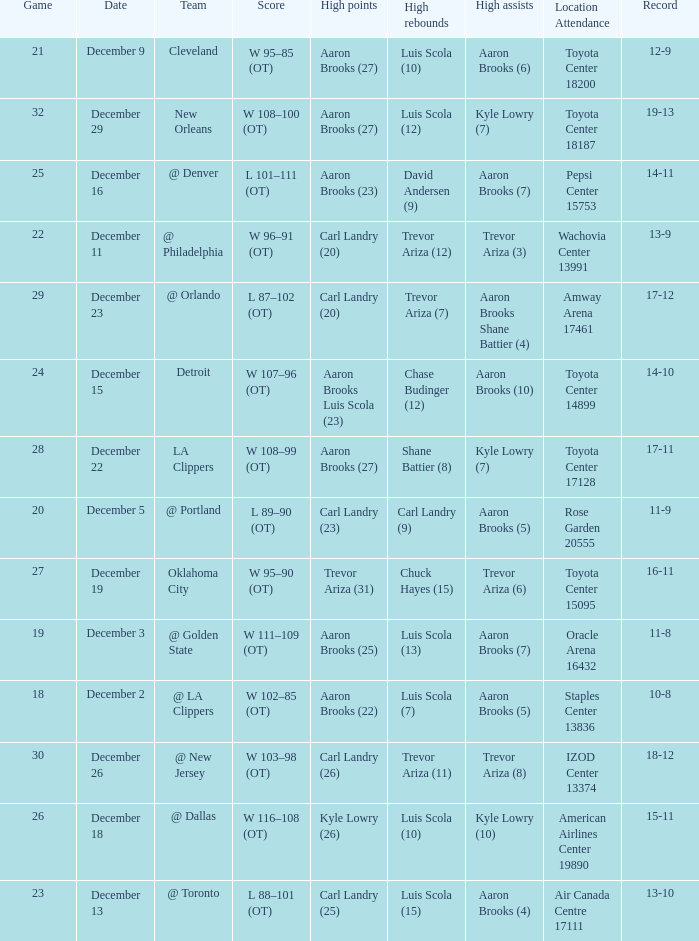Who did the high rebounds in the game where Carl Landry (23) did the most high points? Carl Landry (9). 